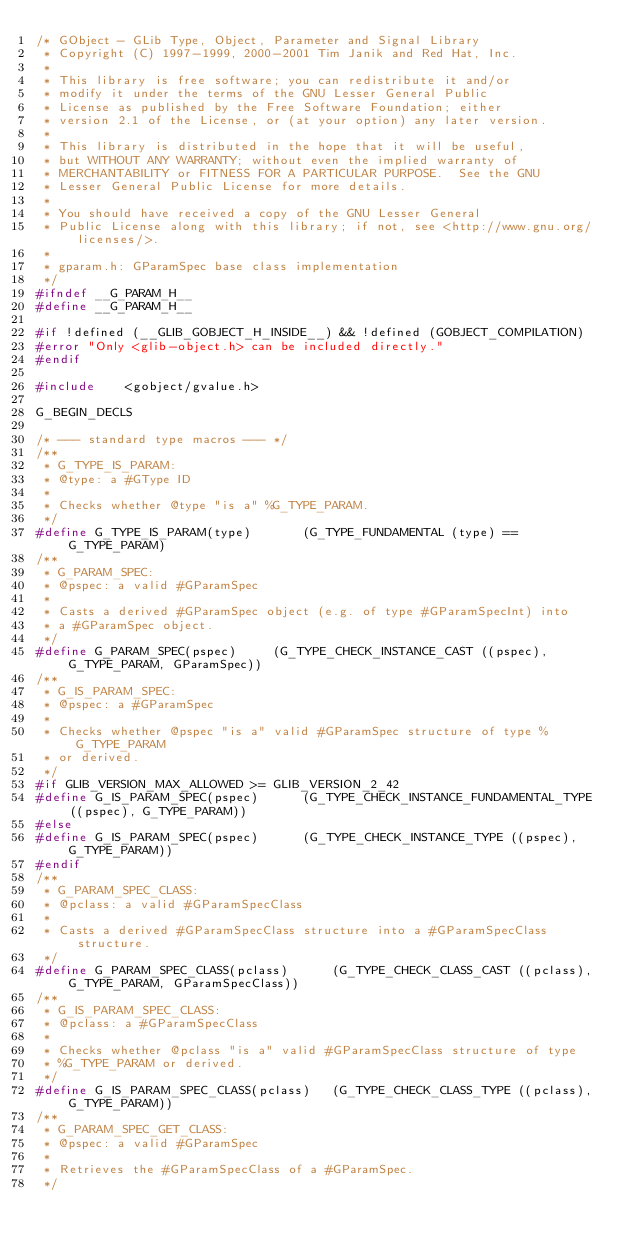Convert code to text. <code><loc_0><loc_0><loc_500><loc_500><_C_>/* GObject - GLib Type, Object, Parameter and Signal Library
 * Copyright (C) 1997-1999, 2000-2001 Tim Janik and Red Hat, Inc.
 *
 * This library is free software; you can redistribute it and/or
 * modify it under the terms of the GNU Lesser General Public
 * License as published by the Free Software Foundation; either
 * version 2.1 of the License, or (at your option) any later version.
 *
 * This library is distributed in the hope that it will be useful,
 * but WITHOUT ANY WARRANTY; without even the implied warranty of
 * MERCHANTABILITY or FITNESS FOR A PARTICULAR PURPOSE.  See the GNU
 * Lesser General Public License for more details.
 *
 * You should have received a copy of the GNU Lesser General
 * Public License along with this library; if not, see <http://www.gnu.org/licenses/>.
 *
 * gparam.h: GParamSpec base class implementation
 */
#ifndef __G_PARAM_H__
#define __G_PARAM_H__

#if !defined (__GLIB_GOBJECT_H_INSIDE__) && !defined (GOBJECT_COMPILATION)
#error "Only <glib-object.h> can be included directly."
#endif

#include	<gobject/gvalue.h>

G_BEGIN_DECLS

/* --- standard type macros --- */
/**
 * G_TYPE_IS_PARAM:
 * @type: a #GType ID
 * 
 * Checks whether @type "is a" %G_TYPE_PARAM.
 */
#define G_TYPE_IS_PARAM(type)		(G_TYPE_FUNDAMENTAL (type) == G_TYPE_PARAM)
/**
 * G_PARAM_SPEC:
 * @pspec: a valid #GParamSpec
 * 
 * Casts a derived #GParamSpec object (e.g. of type #GParamSpecInt) into
 * a #GParamSpec object.
 */
#define G_PARAM_SPEC(pspec)		(G_TYPE_CHECK_INSTANCE_CAST ((pspec), G_TYPE_PARAM, GParamSpec))
/**
 * G_IS_PARAM_SPEC:
 * @pspec: a #GParamSpec
 * 
 * Checks whether @pspec "is a" valid #GParamSpec structure of type %G_TYPE_PARAM
 * or derived.
 */
#if GLIB_VERSION_MAX_ALLOWED >= GLIB_VERSION_2_42
#define G_IS_PARAM_SPEC(pspec)		(G_TYPE_CHECK_INSTANCE_FUNDAMENTAL_TYPE ((pspec), G_TYPE_PARAM))
#else
#define G_IS_PARAM_SPEC(pspec)		(G_TYPE_CHECK_INSTANCE_TYPE ((pspec), G_TYPE_PARAM))
#endif
/**
 * G_PARAM_SPEC_CLASS:
 * @pclass: a valid #GParamSpecClass
 * 
 * Casts a derived #GParamSpecClass structure into a #GParamSpecClass structure.
 */
#define G_PARAM_SPEC_CLASS(pclass)      (G_TYPE_CHECK_CLASS_CAST ((pclass), G_TYPE_PARAM, GParamSpecClass))
/**
 * G_IS_PARAM_SPEC_CLASS:
 * @pclass: a #GParamSpecClass
 * 
 * Checks whether @pclass "is a" valid #GParamSpecClass structure of type 
 * %G_TYPE_PARAM or derived.
 */
#define G_IS_PARAM_SPEC_CLASS(pclass)   (G_TYPE_CHECK_CLASS_TYPE ((pclass), G_TYPE_PARAM))
/**
 * G_PARAM_SPEC_GET_CLASS:
 * @pspec: a valid #GParamSpec
 * 
 * Retrieves the #GParamSpecClass of a #GParamSpec.
 */</code> 